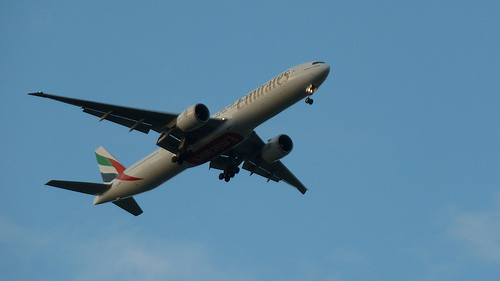What time of day might this photo have been taken? Given the lighting and amount of light in the sky, this photo was likely taken in the late afternoon. 